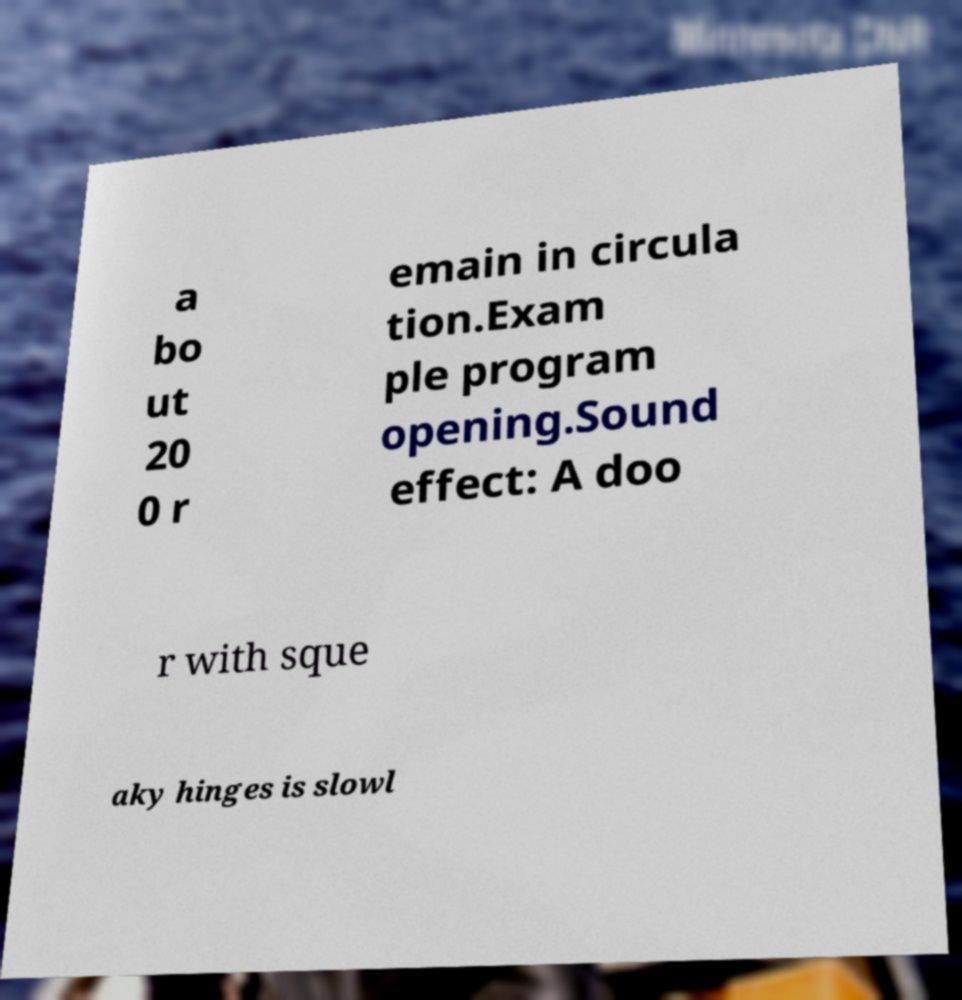Could you extract and type out the text from this image? a bo ut 20 0 r emain in circula tion.Exam ple program opening.Sound effect: A doo r with sque aky hinges is slowl 